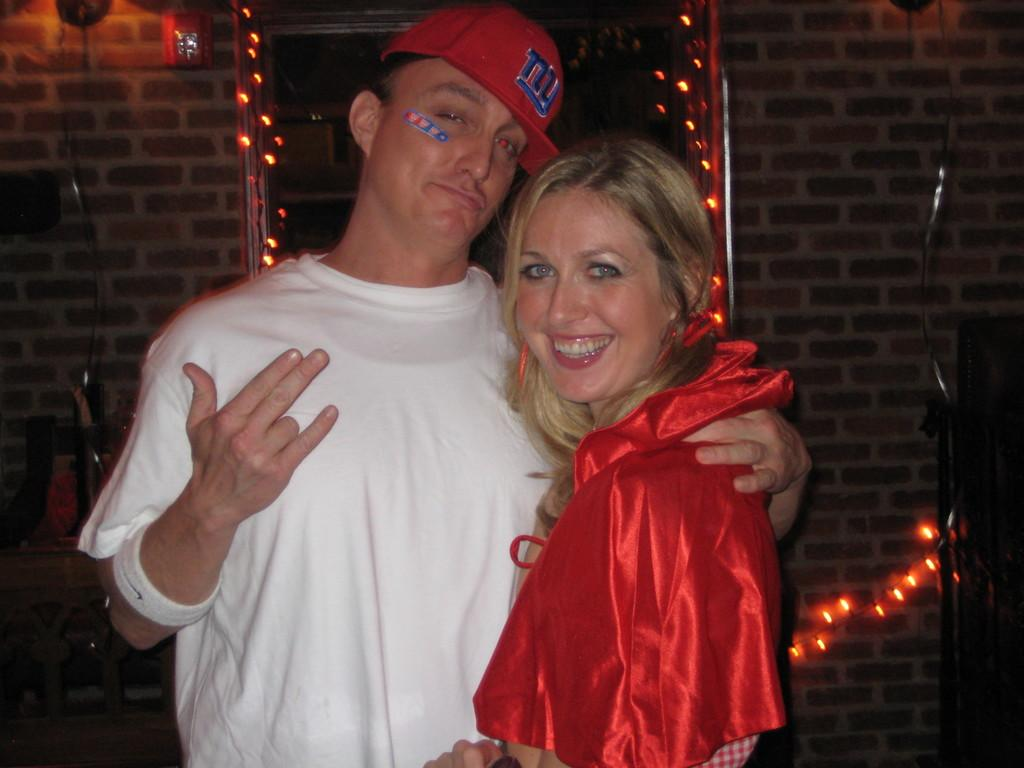How many people are present in the image? There are two people, a man and a woman, present in the image. What are the man and woman doing in the image? The man and woman are holding each other in the image. What can be seen behind the man and woman? There is a wall visible in the image. What object is present that can reflect images? There is a mirror in the image. What type of illumination is visible in the image? There are lights visible in the image. What type of volleyball is being played in the image? There is no volleyball present in the image. What kind of string is being used by the beast in the image? There is no beast or string present in the image. 